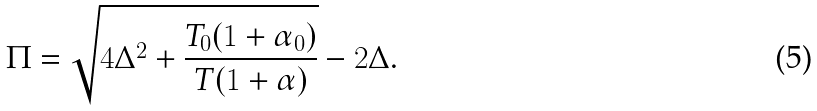<formula> <loc_0><loc_0><loc_500><loc_500>\Pi = \sqrt { 4 \Delta ^ { 2 } + \frac { T _ { 0 } ( 1 + \alpha _ { 0 } ) } { T ( 1 + \alpha ) } } - 2 \Delta .</formula> 